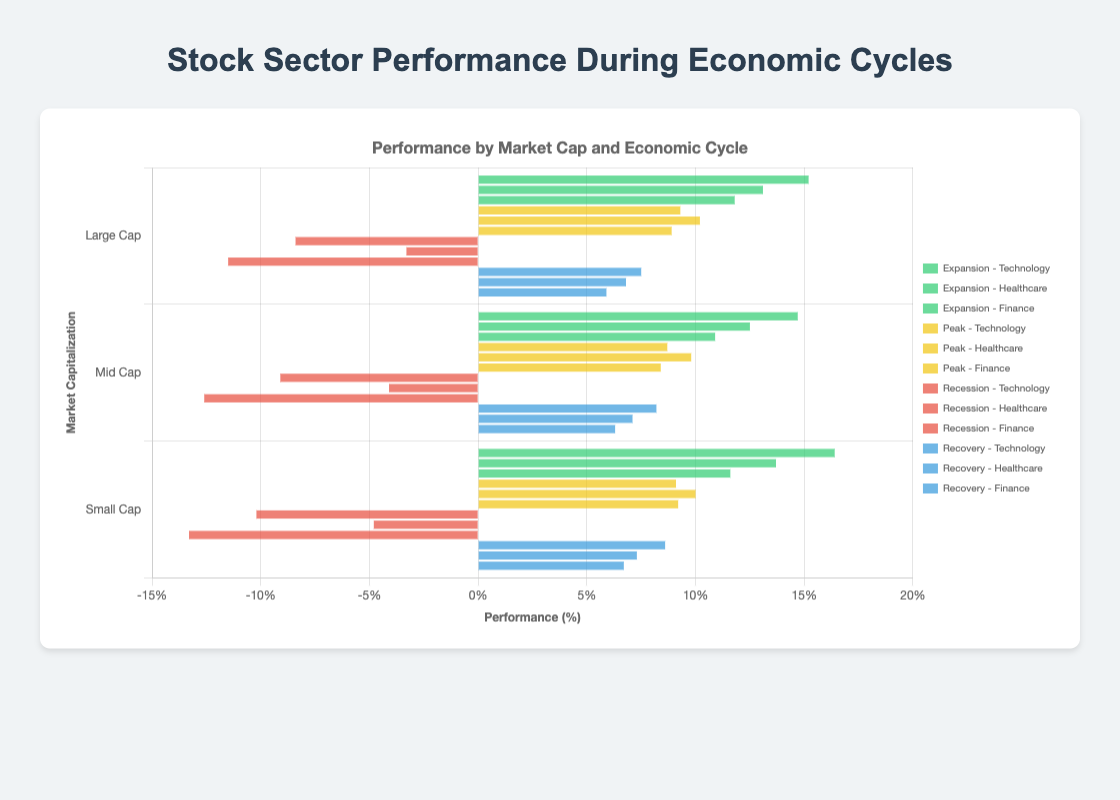What is the performance of Small Cap Technology stocks during the Expansion cycle? Locate the Expansion cycle and the Technology sector in the figure. The performance of Small Cap stocks in this combination is represented by the length of the corresponding bar. It shows a performance of 16.4%.
Answer: 16.4% Which sector had the highest performance during the Recovery cycle? Examine the bars corresponding to the Recovery cycle. Compare the lengths of the bars for Technology, Healthcare, and Finance sectors. The longest bar represents the Technology sector, which has the highest performance.
Answer: Technology By how much did Large Cap Technology outperform Large Cap Finance stocks during the Expansion cycle? Identify the Large Cap bars for Technology and Finance sectors in the Expansion cycle. The performance for Large Cap Technology is 15.2%, and for Large Cap Finance, it is 11.8%. The difference is calculated as 15.2% - 11.8% = 3.4%.
Answer: 3.4% What is the average performance of Mid Cap stocks across all sectors during the Peak cycle? Identify the Mid Cap bars for all sectors (Technology, Healthcare, Finance) during the Peak cycle. Their performances are 8.7%, 9.8%, and 8.4% respectively. The average is calculated as (8.7 + 9.8 + 8.4)/3 = 8.96%.
Answer: 8.96% Which market capitalization category had the worst performance during the Recession cycle and in which sector? Examine the bars in the Recession cycle for all market capitalizations (Large Cap, Mid Cap, Small Cap) and sectors (Technology, Healthcare, Finance). The Small Cap Finance sector has the lowest performance at -13.3%.
Answer: Small Cap Finance Compare the performance of Mid Cap Healthcare stocks between the Expansion and Recovery cycles. Identify the Mid Cap Healthcare bars for both cycles. During Expansion, the performance is 12.5%, while during Recovery, it is 7.1%. The change in performance can be seen as 12.5% - 7.1% = 5.4%. Thus, Mid Cap Healthcare stocks performed 5.4% better in the Expansion cycle compared to Recovery.
Answer: 5.4% better in Expansion What is the combined performance of all sectors for Small Cap stocks during the Recession cycle? Locate the Small Cap bars for all sectors during the Recession cycle. They are -10.2% (Technology), -4.8% (Healthcare), and -13.3% (Finance). Summing these performances gives the combined performance: -10.2 + (-4.8) + (-13.3) = -28.3%.
Answer: -28.3% Which sector has the most stable performance across all economic cycles for Large Cap stocks? Evaluate the Large Cap performance bars for Technology, Healthcare, and Finance across all cycles. The sector with the least variation in bar lengths, indicating stability, is Healthcare (13.1 in Expansion, 10.2 in Peak, -3.3 in Recession, 6.8 in Recovery). Calculate the standard deviation or visually assess the variation. The Healthcare sector shows less variability compared to Technology and Finance.
Answer: Healthcare 